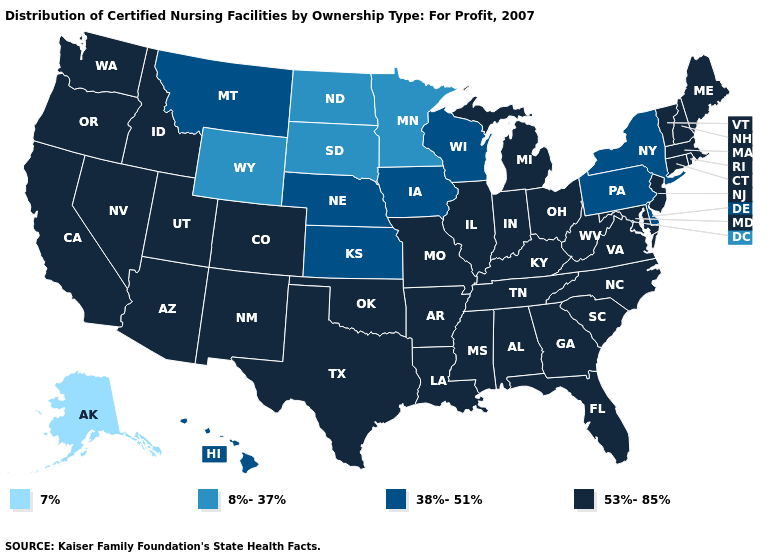Does New Hampshire have a higher value than Nebraska?
Concise answer only. Yes. Does Missouri have the highest value in the MidWest?
Write a very short answer. Yes. Does the map have missing data?
Answer briefly. No. Is the legend a continuous bar?
Keep it brief. No. Name the states that have a value in the range 38%-51%?
Concise answer only. Delaware, Hawaii, Iowa, Kansas, Montana, Nebraska, New York, Pennsylvania, Wisconsin. What is the lowest value in states that border Montana?
Concise answer only. 8%-37%. Does the first symbol in the legend represent the smallest category?
Concise answer only. Yes. Name the states that have a value in the range 53%-85%?
Concise answer only. Alabama, Arizona, Arkansas, California, Colorado, Connecticut, Florida, Georgia, Idaho, Illinois, Indiana, Kentucky, Louisiana, Maine, Maryland, Massachusetts, Michigan, Mississippi, Missouri, Nevada, New Hampshire, New Jersey, New Mexico, North Carolina, Ohio, Oklahoma, Oregon, Rhode Island, South Carolina, Tennessee, Texas, Utah, Vermont, Virginia, Washington, West Virginia. Name the states that have a value in the range 8%-37%?
Be succinct. Minnesota, North Dakota, South Dakota, Wyoming. Does Pennsylvania have the highest value in the USA?
Answer briefly. No. Which states have the highest value in the USA?
Keep it brief. Alabama, Arizona, Arkansas, California, Colorado, Connecticut, Florida, Georgia, Idaho, Illinois, Indiana, Kentucky, Louisiana, Maine, Maryland, Massachusetts, Michigan, Mississippi, Missouri, Nevada, New Hampshire, New Jersey, New Mexico, North Carolina, Ohio, Oklahoma, Oregon, Rhode Island, South Carolina, Tennessee, Texas, Utah, Vermont, Virginia, Washington, West Virginia. Name the states that have a value in the range 8%-37%?
Answer briefly. Minnesota, North Dakota, South Dakota, Wyoming. What is the highest value in states that border Utah?
Concise answer only. 53%-85%. Which states have the lowest value in the South?
Answer briefly. Delaware. Name the states that have a value in the range 53%-85%?
Concise answer only. Alabama, Arizona, Arkansas, California, Colorado, Connecticut, Florida, Georgia, Idaho, Illinois, Indiana, Kentucky, Louisiana, Maine, Maryland, Massachusetts, Michigan, Mississippi, Missouri, Nevada, New Hampshire, New Jersey, New Mexico, North Carolina, Ohio, Oklahoma, Oregon, Rhode Island, South Carolina, Tennessee, Texas, Utah, Vermont, Virginia, Washington, West Virginia. 